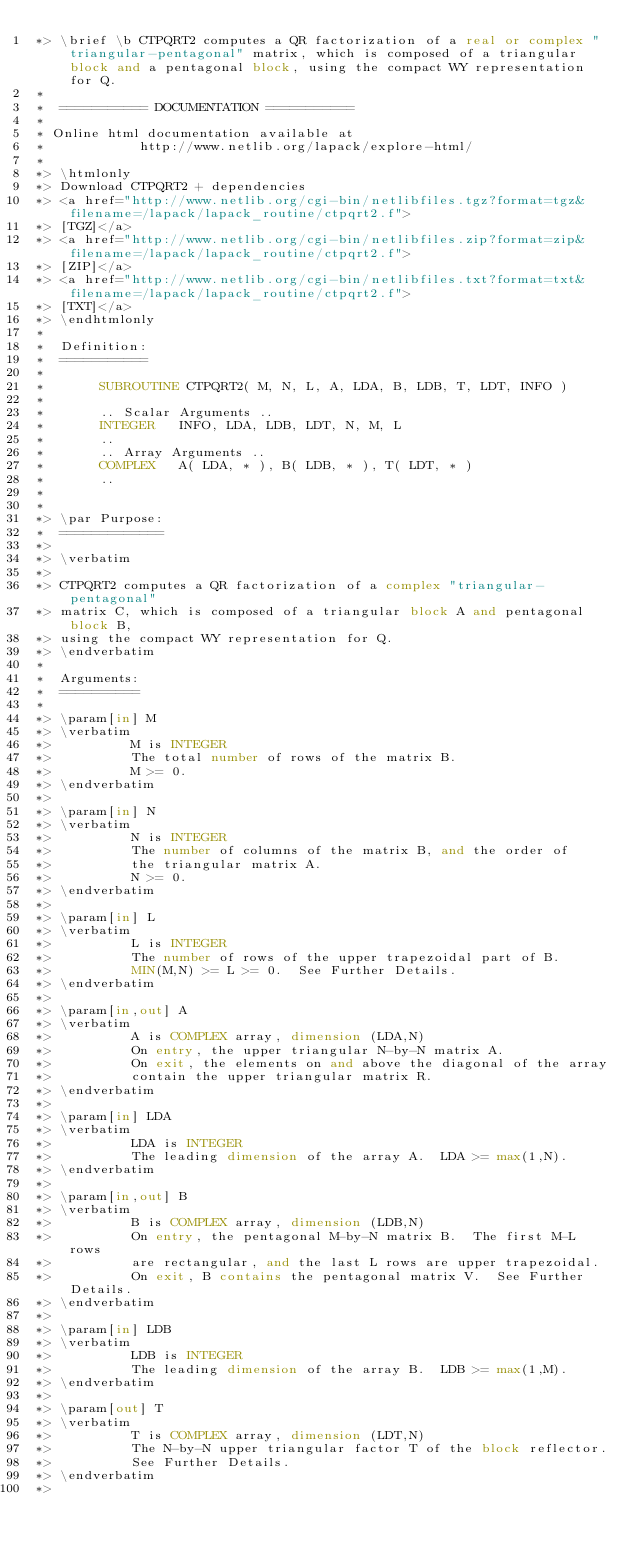<code> <loc_0><loc_0><loc_500><loc_500><_FORTRAN_>*> \brief \b CTPQRT2 computes a QR factorization of a real or complex "triangular-pentagonal" matrix, which is composed of a triangular block and a pentagonal block, using the compact WY representation for Q.
*
*  =========== DOCUMENTATION ===========
*
* Online html documentation available at 
*            http://www.netlib.org/lapack/explore-html/ 
*
*> \htmlonly
*> Download CTPQRT2 + dependencies 
*> <a href="http://www.netlib.org/cgi-bin/netlibfiles.tgz?format=tgz&filename=/lapack/lapack_routine/ctpqrt2.f"> 
*> [TGZ]</a> 
*> <a href="http://www.netlib.org/cgi-bin/netlibfiles.zip?format=zip&filename=/lapack/lapack_routine/ctpqrt2.f"> 
*> [ZIP]</a> 
*> <a href="http://www.netlib.org/cgi-bin/netlibfiles.txt?format=txt&filename=/lapack/lapack_routine/ctpqrt2.f"> 
*> [TXT]</a>
*> \endhtmlonly 
*
*  Definition:
*  ===========
*
*       SUBROUTINE CTPQRT2( M, N, L, A, LDA, B, LDB, T, LDT, INFO )
* 
*       .. Scalar Arguments ..
*       INTEGER   INFO, LDA, LDB, LDT, N, M, L
*       ..
*       .. Array Arguments ..
*       COMPLEX   A( LDA, * ), B( LDB, * ), T( LDT, * )
*       ..
*  
*
*> \par Purpose:
*  =============
*>
*> \verbatim
*>
*> CTPQRT2 computes a QR factorization of a complex "triangular-pentagonal"
*> matrix C, which is composed of a triangular block A and pentagonal block B, 
*> using the compact WY representation for Q.
*> \endverbatim
*
*  Arguments:
*  ==========
*
*> \param[in] M
*> \verbatim
*>          M is INTEGER
*>          The total number of rows of the matrix B.  
*>          M >= 0.
*> \endverbatim
*>
*> \param[in] N
*> \verbatim
*>          N is INTEGER
*>          The number of columns of the matrix B, and the order of
*>          the triangular matrix A.
*>          N >= 0.
*> \endverbatim
*>
*> \param[in] L
*> \verbatim
*>          L is INTEGER
*>          The number of rows of the upper trapezoidal part of B.  
*>          MIN(M,N) >= L >= 0.  See Further Details.
*> \endverbatim
*>
*> \param[in,out] A
*> \verbatim
*>          A is COMPLEX array, dimension (LDA,N)
*>          On entry, the upper triangular N-by-N matrix A.
*>          On exit, the elements on and above the diagonal of the array
*>          contain the upper triangular matrix R.
*> \endverbatim
*>
*> \param[in] LDA
*> \verbatim
*>          LDA is INTEGER
*>          The leading dimension of the array A.  LDA >= max(1,N).
*> \endverbatim
*>
*> \param[in,out] B
*> \verbatim
*>          B is COMPLEX array, dimension (LDB,N)
*>          On entry, the pentagonal M-by-N matrix B.  The first M-L rows 
*>          are rectangular, and the last L rows are upper trapezoidal.
*>          On exit, B contains the pentagonal matrix V.  See Further Details.
*> \endverbatim
*>
*> \param[in] LDB
*> \verbatim
*>          LDB is INTEGER
*>          The leading dimension of the array B.  LDB >= max(1,M).
*> \endverbatim
*>
*> \param[out] T
*> \verbatim
*>          T is COMPLEX array, dimension (LDT,N)
*>          The N-by-N upper triangular factor T of the block reflector.
*>          See Further Details.
*> \endverbatim
*></code> 